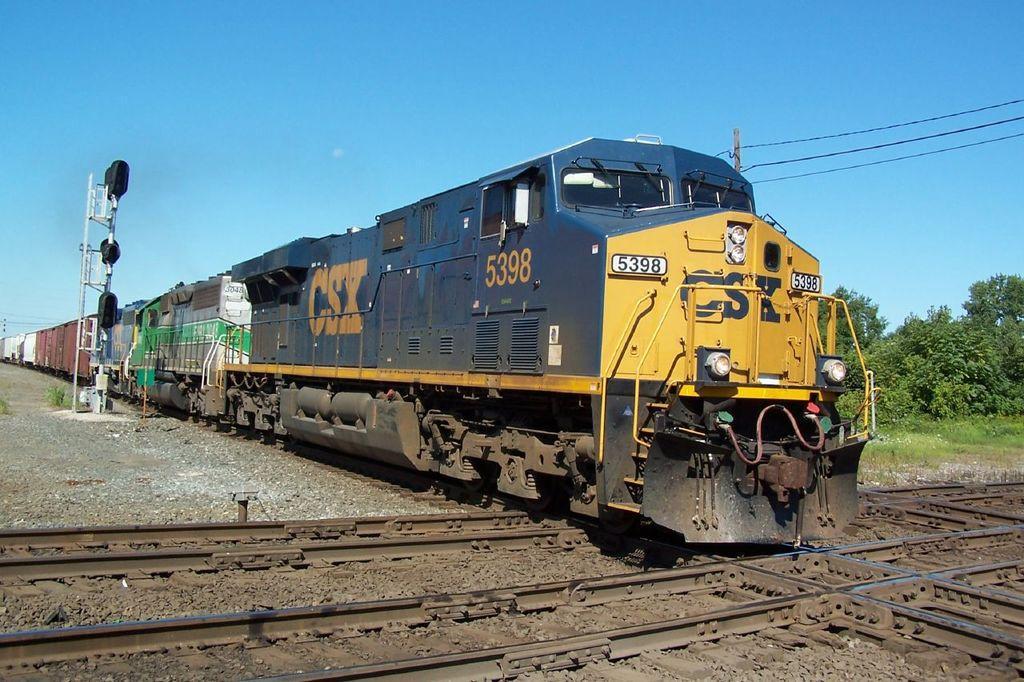Please provide a concise description of this image. In this image we can see a train on the track. We can also see some trees, a pole with wires, stones, grass and the sky which looks cloudy. 